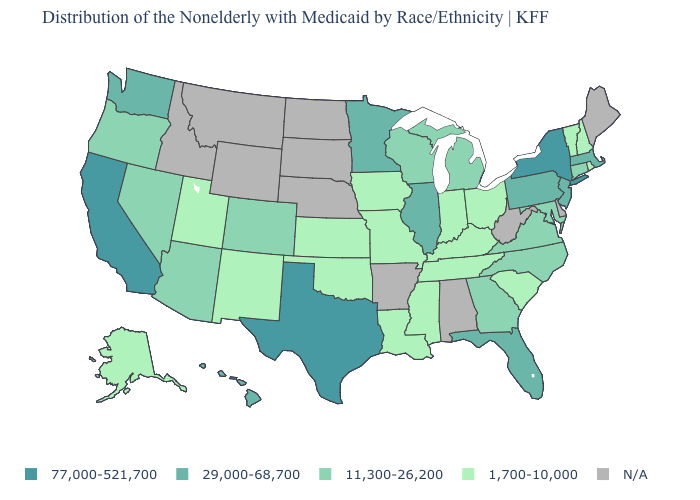Does the map have missing data?
Be succinct. Yes. What is the highest value in the USA?
Write a very short answer. 77,000-521,700. Name the states that have a value in the range 1,700-10,000?
Write a very short answer. Alaska, Indiana, Iowa, Kansas, Kentucky, Louisiana, Mississippi, Missouri, New Hampshire, New Mexico, Ohio, Oklahoma, Rhode Island, South Carolina, Tennessee, Utah, Vermont. What is the value of New York?
Keep it brief. 77,000-521,700. What is the lowest value in the USA?
Be succinct. 1,700-10,000. Does Ohio have the lowest value in the MidWest?
Quick response, please. Yes. What is the value of Maryland?
Give a very brief answer. 11,300-26,200. Among the states that border Oregon , does California have the lowest value?
Concise answer only. No. Name the states that have a value in the range 11,300-26,200?
Write a very short answer. Arizona, Colorado, Connecticut, Georgia, Maryland, Michigan, Nevada, North Carolina, Oregon, Virginia, Wisconsin. What is the highest value in the USA?
Concise answer only. 77,000-521,700. How many symbols are there in the legend?
Be succinct. 5. Among the states that border New Jersey , does Pennsylvania have the lowest value?
Concise answer only. Yes. Does the map have missing data?
Concise answer only. Yes. Name the states that have a value in the range 11,300-26,200?
Short answer required. Arizona, Colorado, Connecticut, Georgia, Maryland, Michigan, Nevada, North Carolina, Oregon, Virginia, Wisconsin. 